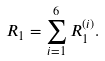Convert formula to latex. <formula><loc_0><loc_0><loc_500><loc_500>R _ { 1 } = \sum _ { i = 1 } ^ { 6 } R _ { 1 } ^ { ( i ) } .</formula> 